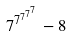<formula> <loc_0><loc_0><loc_500><loc_500>7 ^ { 7 ^ { 7 ^ { 7 ^ { 7 } } } } - 8</formula> 